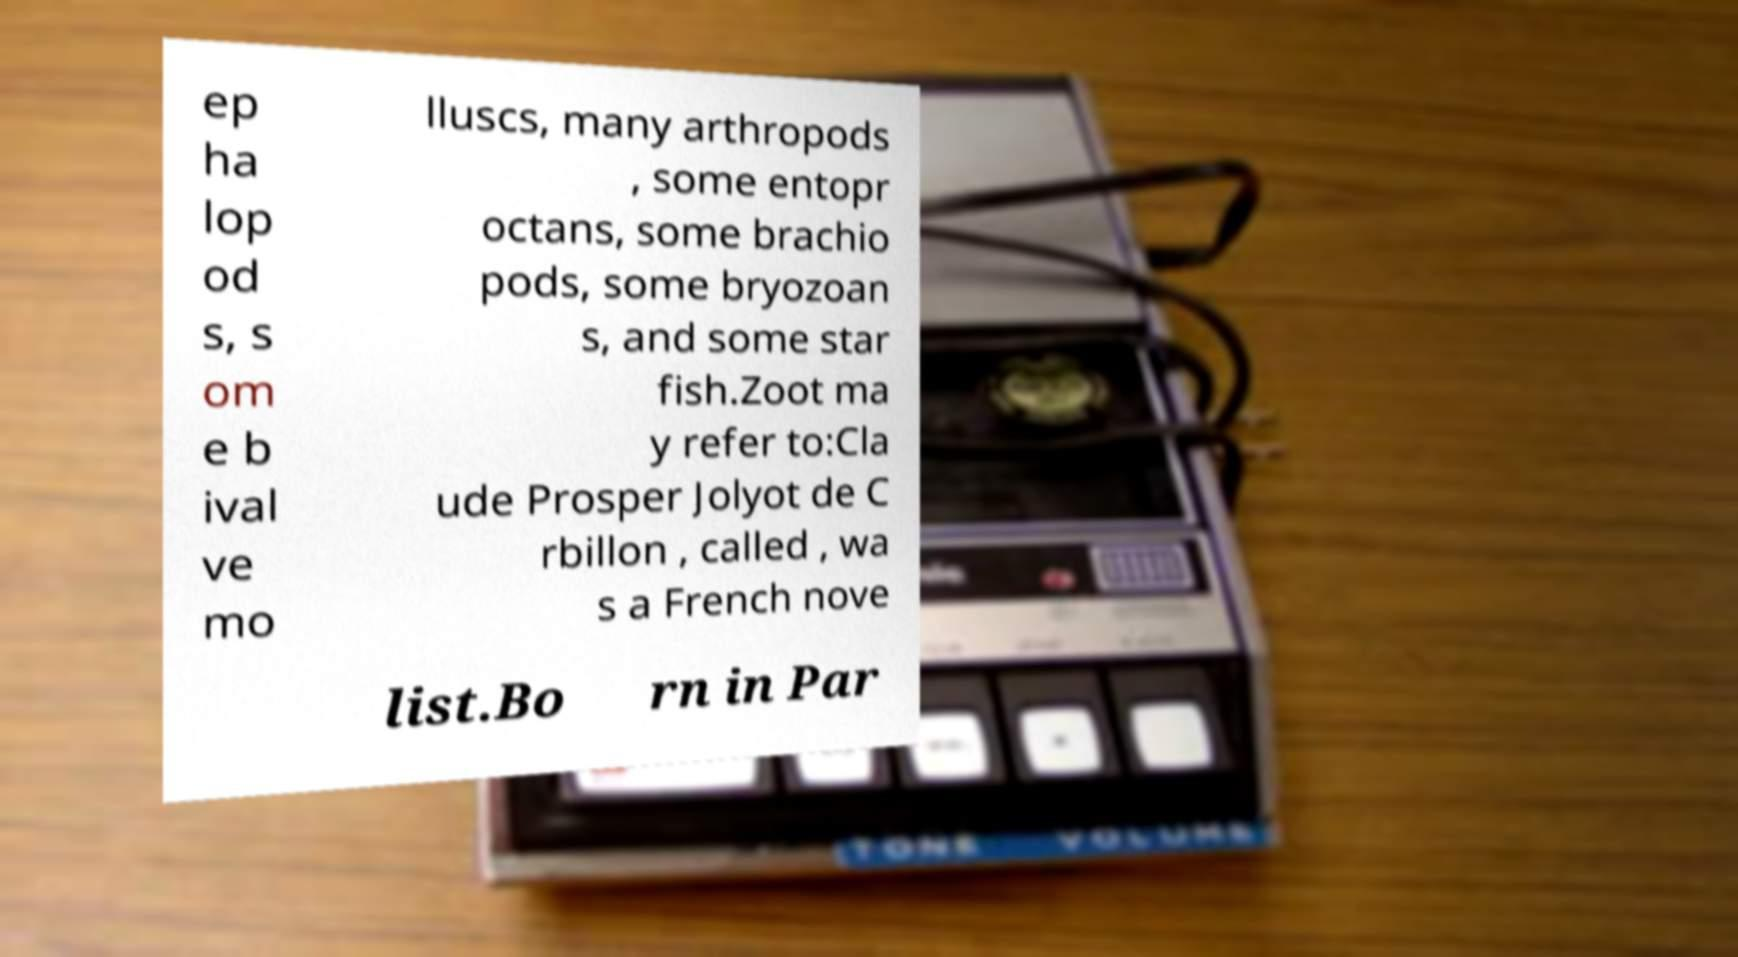For documentation purposes, I need the text within this image transcribed. Could you provide that? ep ha lop od s, s om e b ival ve mo lluscs, many arthropods , some entopr octans, some brachio pods, some bryozoan s, and some star fish.Zoot ma y refer to:Cla ude Prosper Jolyot de C rbillon , called , wa s a French nove list.Bo rn in Par 